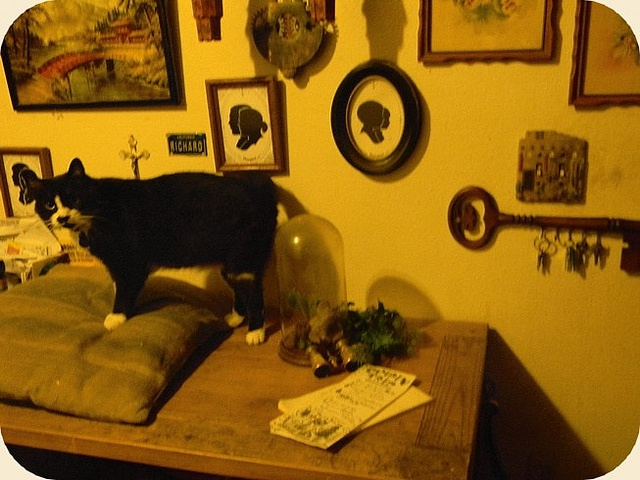Describe the objects in this image and their specific colors. I can see a cat in beige, black, maroon, orange, and olive tones in this image. 